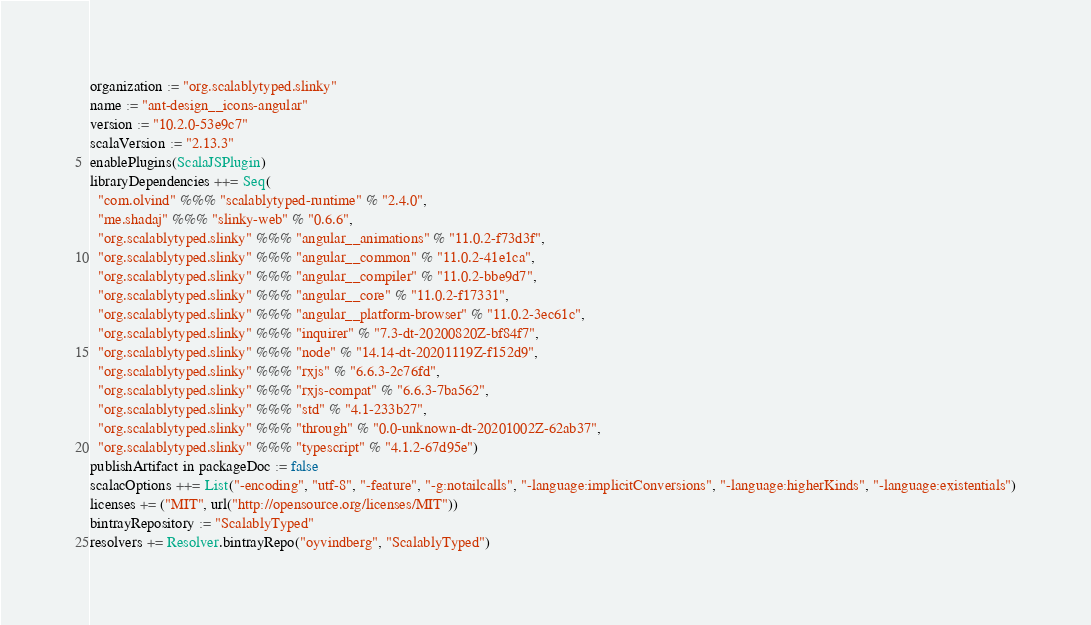Convert code to text. <code><loc_0><loc_0><loc_500><loc_500><_Scala_>organization := "org.scalablytyped.slinky"
name := "ant-design__icons-angular"
version := "10.2.0-53e9c7"
scalaVersion := "2.13.3"
enablePlugins(ScalaJSPlugin)
libraryDependencies ++= Seq(
  "com.olvind" %%% "scalablytyped-runtime" % "2.4.0",
  "me.shadaj" %%% "slinky-web" % "0.6.6",
  "org.scalablytyped.slinky" %%% "angular__animations" % "11.0.2-f73d3f",
  "org.scalablytyped.slinky" %%% "angular__common" % "11.0.2-41e1ca",
  "org.scalablytyped.slinky" %%% "angular__compiler" % "11.0.2-bbe9d7",
  "org.scalablytyped.slinky" %%% "angular__core" % "11.0.2-f17331",
  "org.scalablytyped.slinky" %%% "angular__platform-browser" % "11.0.2-3ec61c",
  "org.scalablytyped.slinky" %%% "inquirer" % "7.3-dt-20200820Z-bf84f7",
  "org.scalablytyped.slinky" %%% "node" % "14.14-dt-20201119Z-f152d9",
  "org.scalablytyped.slinky" %%% "rxjs" % "6.6.3-2c76fd",
  "org.scalablytyped.slinky" %%% "rxjs-compat" % "6.6.3-7ba562",
  "org.scalablytyped.slinky" %%% "std" % "4.1-233b27",
  "org.scalablytyped.slinky" %%% "through" % "0.0-unknown-dt-20201002Z-62ab37",
  "org.scalablytyped.slinky" %%% "typescript" % "4.1.2-67d95e")
publishArtifact in packageDoc := false
scalacOptions ++= List("-encoding", "utf-8", "-feature", "-g:notailcalls", "-language:implicitConversions", "-language:higherKinds", "-language:existentials")
licenses += ("MIT", url("http://opensource.org/licenses/MIT"))
bintrayRepository := "ScalablyTyped"
resolvers += Resolver.bintrayRepo("oyvindberg", "ScalablyTyped")
</code> 